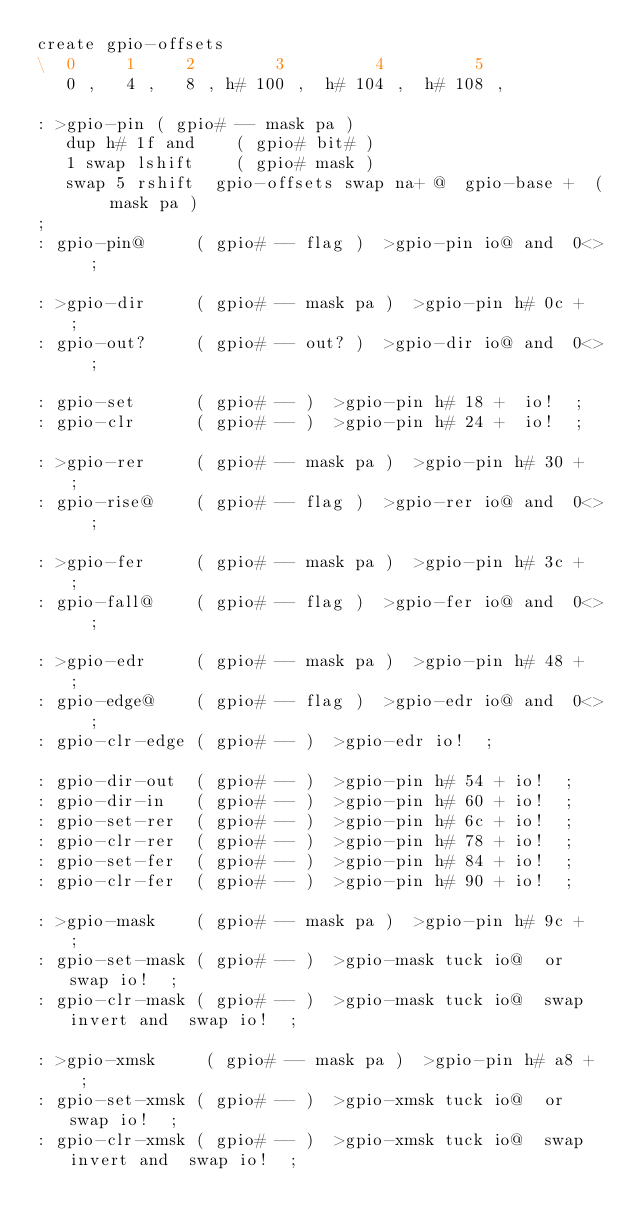Convert code to text. <code><loc_0><loc_0><loc_500><loc_500><_Forth_>create gpio-offsets
\  0     1     2        3         4         5
   0 ,   4 ,   8 , h# 100 ,  h# 104 ,  h# 108 ,

: >gpio-pin ( gpio# -- mask pa )
   dup h# 1f and    ( gpio# bit# )
   1 swap lshift    ( gpio# mask )
   swap 5 rshift  gpio-offsets swap na+ @  gpio-base +  ( mask pa )
;
: gpio-pin@     ( gpio# -- flag )  >gpio-pin io@ and  0<>  ;

: >gpio-dir     ( gpio# -- mask pa )  >gpio-pin h# 0c +  ;
: gpio-out?     ( gpio# -- out? )  >gpio-dir io@ and  0<>  ;

: gpio-set      ( gpio# -- )  >gpio-pin h# 18 +  io!  ;
: gpio-clr      ( gpio# -- )  >gpio-pin h# 24 +  io!  ;

: >gpio-rer     ( gpio# -- mask pa )  >gpio-pin h# 30 +  ;
: gpio-rise@    ( gpio# -- flag )  >gpio-rer io@ and  0<>  ;

: >gpio-fer     ( gpio# -- mask pa )  >gpio-pin h# 3c +  ;
: gpio-fall@    ( gpio# -- flag )  >gpio-fer io@ and  0<>  ;

: >gpio-edr     ( gpio# -- mask pa )  >gpio-pin h# 48 +  ;
: gpio-edge@    ( gpio# -- flag )  >gpio-edr io@ and  0<>  ;
: gpio-clr-edge ( gpio# -- )  >gpio-edr io!  ;

: gpio-dir-out  ( gpio# -- )  >gpio-pin h# 54 + io!  ;
: gpio-dir-in   ( gpio# -- )  >gpio-pin h# 60 + io!  ;
: gpio-set-rer  ( gpio# -- )  >gpio-pin h# 6c + io!  ;
: gpio-clr-rer  ( gpio# -- )  >gpio-pin h# 78 + io!  ;
: gpio-set-fer  ( gpio# -- )  >gpio-pin h# 84 + io!  ;
: gpio-clr-fer  ( gpio# -- )  >gpio-pin h# 90 + io!  ;

: >gpio-mask    ( gpio# -- mask pa )  >gpio-pin h# 9c +  ;
: gpio-set-mask ( gpio# -- )  >gpio-mask tuck io@  or  swap io!  ;
: gpio-clr-mask ( gpio# -- )  >gpio-mask tuck io@  swap invert and  swap io!  ;

: >gpio-xmsk     ( gpio# -- mask pa )  >gpio-pin h# a8 +  ;
: gpio-set-xmsk ( gpio# -- )  >gpio-xmsk tuck io@  or  swap io!  ;
: gpio-clr-xmsk ( gpio# -- )  >gpio-xmsk tuck io@  swap invert and  swap io!  ;
</code> 